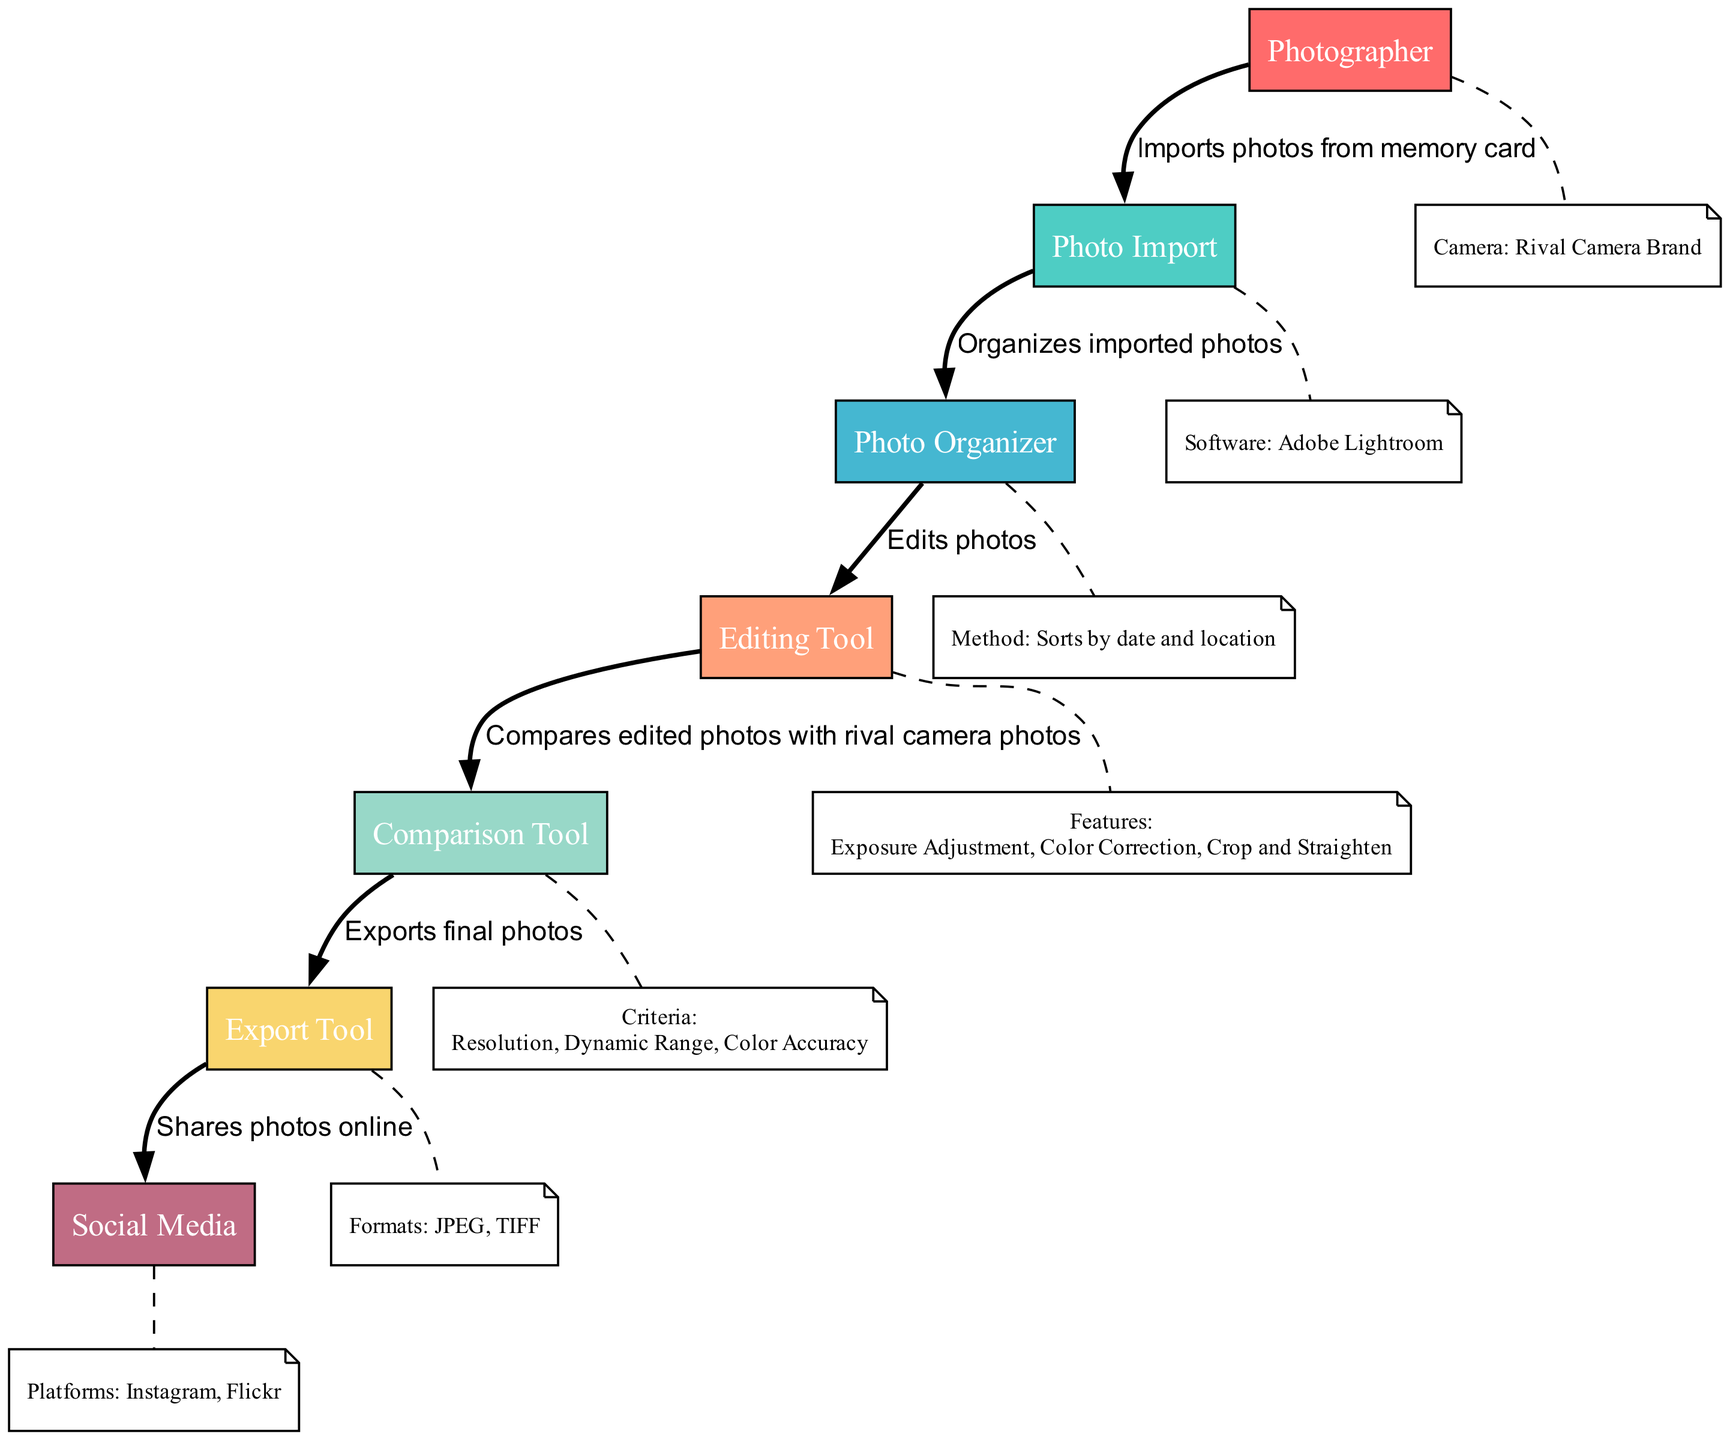What is the first action performed in the workflow? The first action in the workflow is performed by the Photographer, who takes photos. This is shown as the initial node in the diagram where the flow begins.
Answer: Takes photos How many edges are in the diagram? The edges represent the actions taken between different nodes. By counting each of the connections made between the actors in the sequence, there are a total of 6 edges connecting 7 nodes.
Answer: 6 What software is used for photo import? The software used for importing photos from the memory card is Adobe Lightroom, as indicated in the node corresponding to the Photo Import actor.
Answer: Adobe Lightroom Which tool compares the edited photos? The Comparison Tool is responsible for comparing the edited photos. This is explicitly detailed in the action related to the Comparison Tool in the diagram.
Answer: Comparison Tool What features are included in the editing tool? The Editing Tool has features such as Exposure Adjustment, Color Correction, and Crop and Straighten. The diagram lists these features under the respective Editing Tool node, showing what can be done.
Answer: Exposure Adjustment, Color Correction, Crop and Straighten What action happens after the Photo Organizer? After the Photo Organizer organizes the imported photos, the next action is to edit the photos using the Editing Tool. This sequence of action is shown by the arrow connecting these two actors in the workflow.
Answer: Edits photos Which platforms are used for sharing photos online? The platforms used for sharing photos online are Instagram and Flickr, listed under the Social Media actor node in the diagram.
Answer: Instagram, Flickr What are the criteria used in the comparison tool? The criteria evaluated by the Comparison Tool include Resolution, Dynamic Range, and Color Accuracy. The diagram clearly states these criteria under the respective node for the Comparison Tool.
Answer: Resolution, Dynamic Range, Color Accuracy 